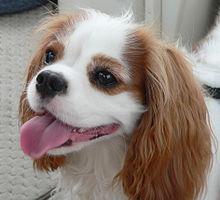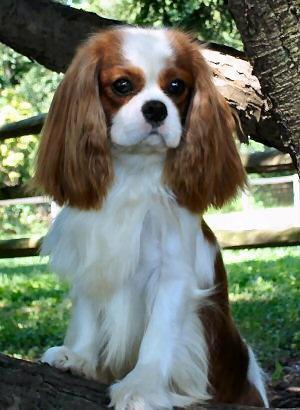The first image is the image on the left, the second image is the image on the right. Examine the images to the left and right. Is the description "There is a single brown and white cocker spaniel looking left." accurate? Answer yes or no. Yes. The first image is the image on the left, the second image is the image on the right. Evaluate the accuracy of this statement regarding the images: "There are three dogs, and one is looking straight at the camera.". Is it true? Answer yes or no. No. 